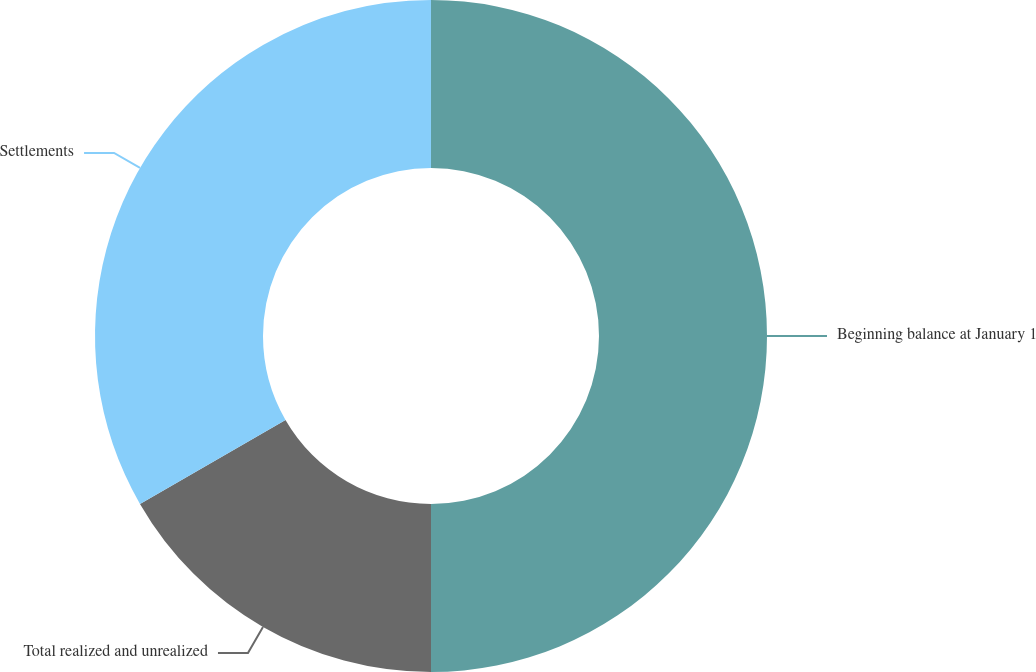<chart> <loc_0><loc_0><loc_500><loc_500><pie_chart><fcel>Beginning balance at January 1<fcel>Total realized and unrealized<fcel>Settlements<nl><fcel>50.0%<fcel>16.67%<fcel>33.33%<nl></chart> 